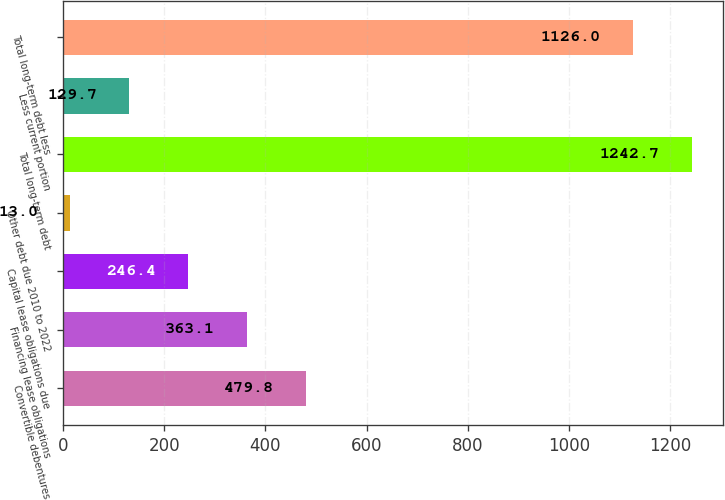<chart> <loc_0><loc_0><loc_500><loc_500><bar_chart><fcel>Convertible debentures<fcel>Financing lease obligations<fcel>Capital lease obligations due<fcel>Other debt due 2010 to 2022<fcel>Total long-term debt<fcel>Less current portion<fcel>Total long-term debt less<nl><fcel>479.8<fcel>363.1<fcel>246.4<fcel>13<fcel>1242.7<fcel>129.7<fcel>1126<nl></chart> 